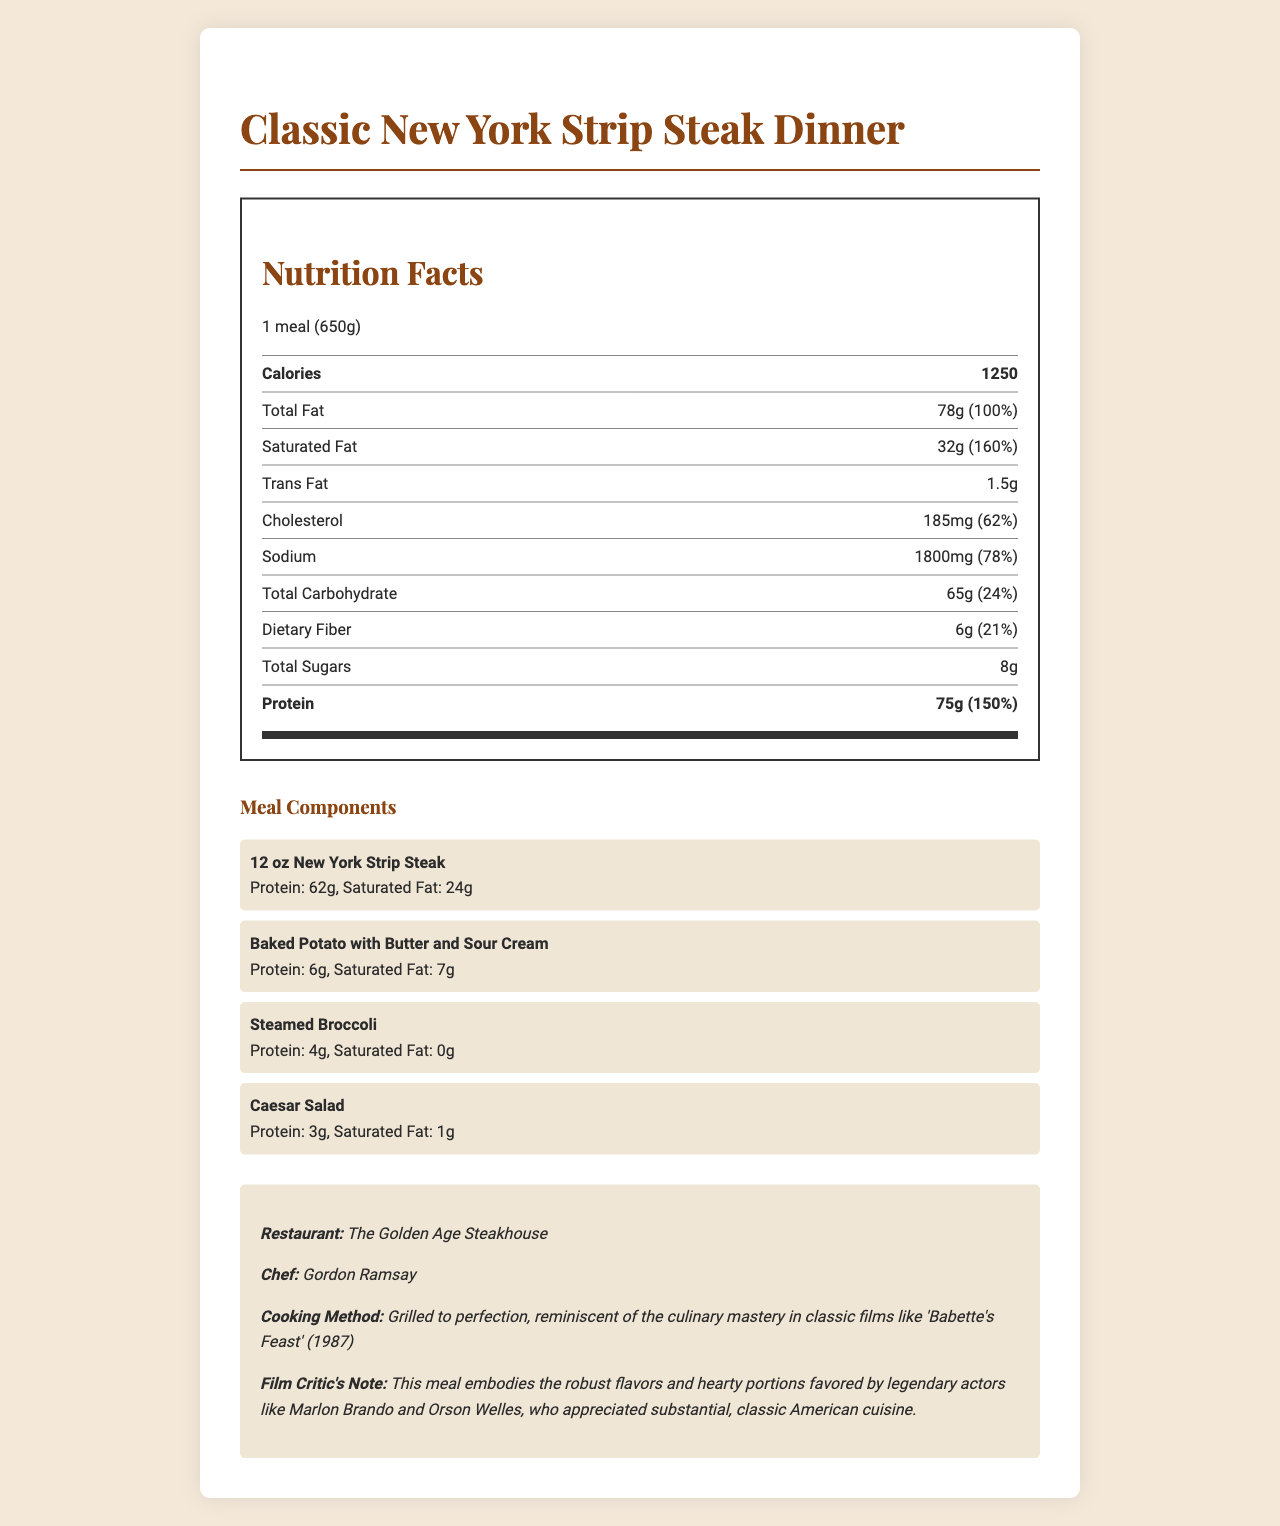How many grams of protein are in the Classic New York Strip Steak Dinner? The document states that the total protein content of the meal is 75 grams.
Answer: 75 grams What is the percentage of the daily value for saturated fat in the Classic New York Strip Steak Dinner? The document indicates that the saturated fat content is 32 grams, which accounts for 160% of the daily value.
Answer: 160% How much saturated fat is in the Baked Potato with Butter and Sour Cream? The meal component section lists the saturated fat content of the Baked Potato with Butter and Sour Cream as 7 grams.
Answer: 7 grams What is the total calorie content of the entire meal? The document mentions that the total calorie content of the meal is 1250 calories.
Answer: 1250 calories List two main components of the Classic New York Strip Steak Dinner and their respective protein content. The New York Strip Steak has 62 grams of protein, and the Baked Potato with Butter and Sour Cream has 6 grams of protein according to the meal components section.
Answer: New York Strip Steak: 62 grams, Baked Potato with Butter and Sour Cream: 6 grams Which component has the highest saturated fat content? A. Steamed Broccoli B. Caesar Salad C. New York Strip Steak The New York Strip Steak has 24 grams of saturated fat, which is the highest among the meal components listed.
Answer: C What percentage of the daily value for protein does the meal provide? A. 120% B. 150% C. 160% The meal provides 75 grams of protein, which accounts for 150% of the daily value, as indicated in the nutrition facts section.
Answer: B How much trans fat does the meal contain? The trans fat content listed in the nutrition facts section is 1.5 grams.
Answer: 1.5 grams Does the Classic New York Strip Steak Dinner provide any Vitamin D? The document states that the meal contains 0.5 micrograms of Vitamin D, which is 3% of the daily value.
Answer: Yes Is the Classic New York Strip Steak Dinner high in cholesterol? The meal contains 185 milligrams of cholesterol, which is 62% of the daily value, indicating it is high in cholesterol.
Answer: Yes Summarize the main nutritional points of the Classic New York Strip Steak Dinner. This summary captures the key nutritional information and components of the meal, prepared by a renowned chef in a classic steakhouse setting.
Answer: The Classic New York Strip Steak Dinner contains 1250 calories, 78 grams of total fat, 32 grams of saturated fat, 1.5 grams of trans fat, 185 milligrams of cholesterol, 1800 milligrams of sodium, 65 grams of carbohydrates, 6 grams of dietary fiber, and 75 grams of protein. The meal components include a New York Strip Steak, Baked Potato with Butter and Sour Cream, Steamed Broccoli, and Caesar Salad. The meal is prepared by chef Gordon Ramsay at The Golden Age Steakhouse. What is the exact amount of Vitamin C in the Classic New York Strip Steak Dinner? The document does not provide any information on Vitamin C content, so this cannot be determined.
Answer: Not enough information 